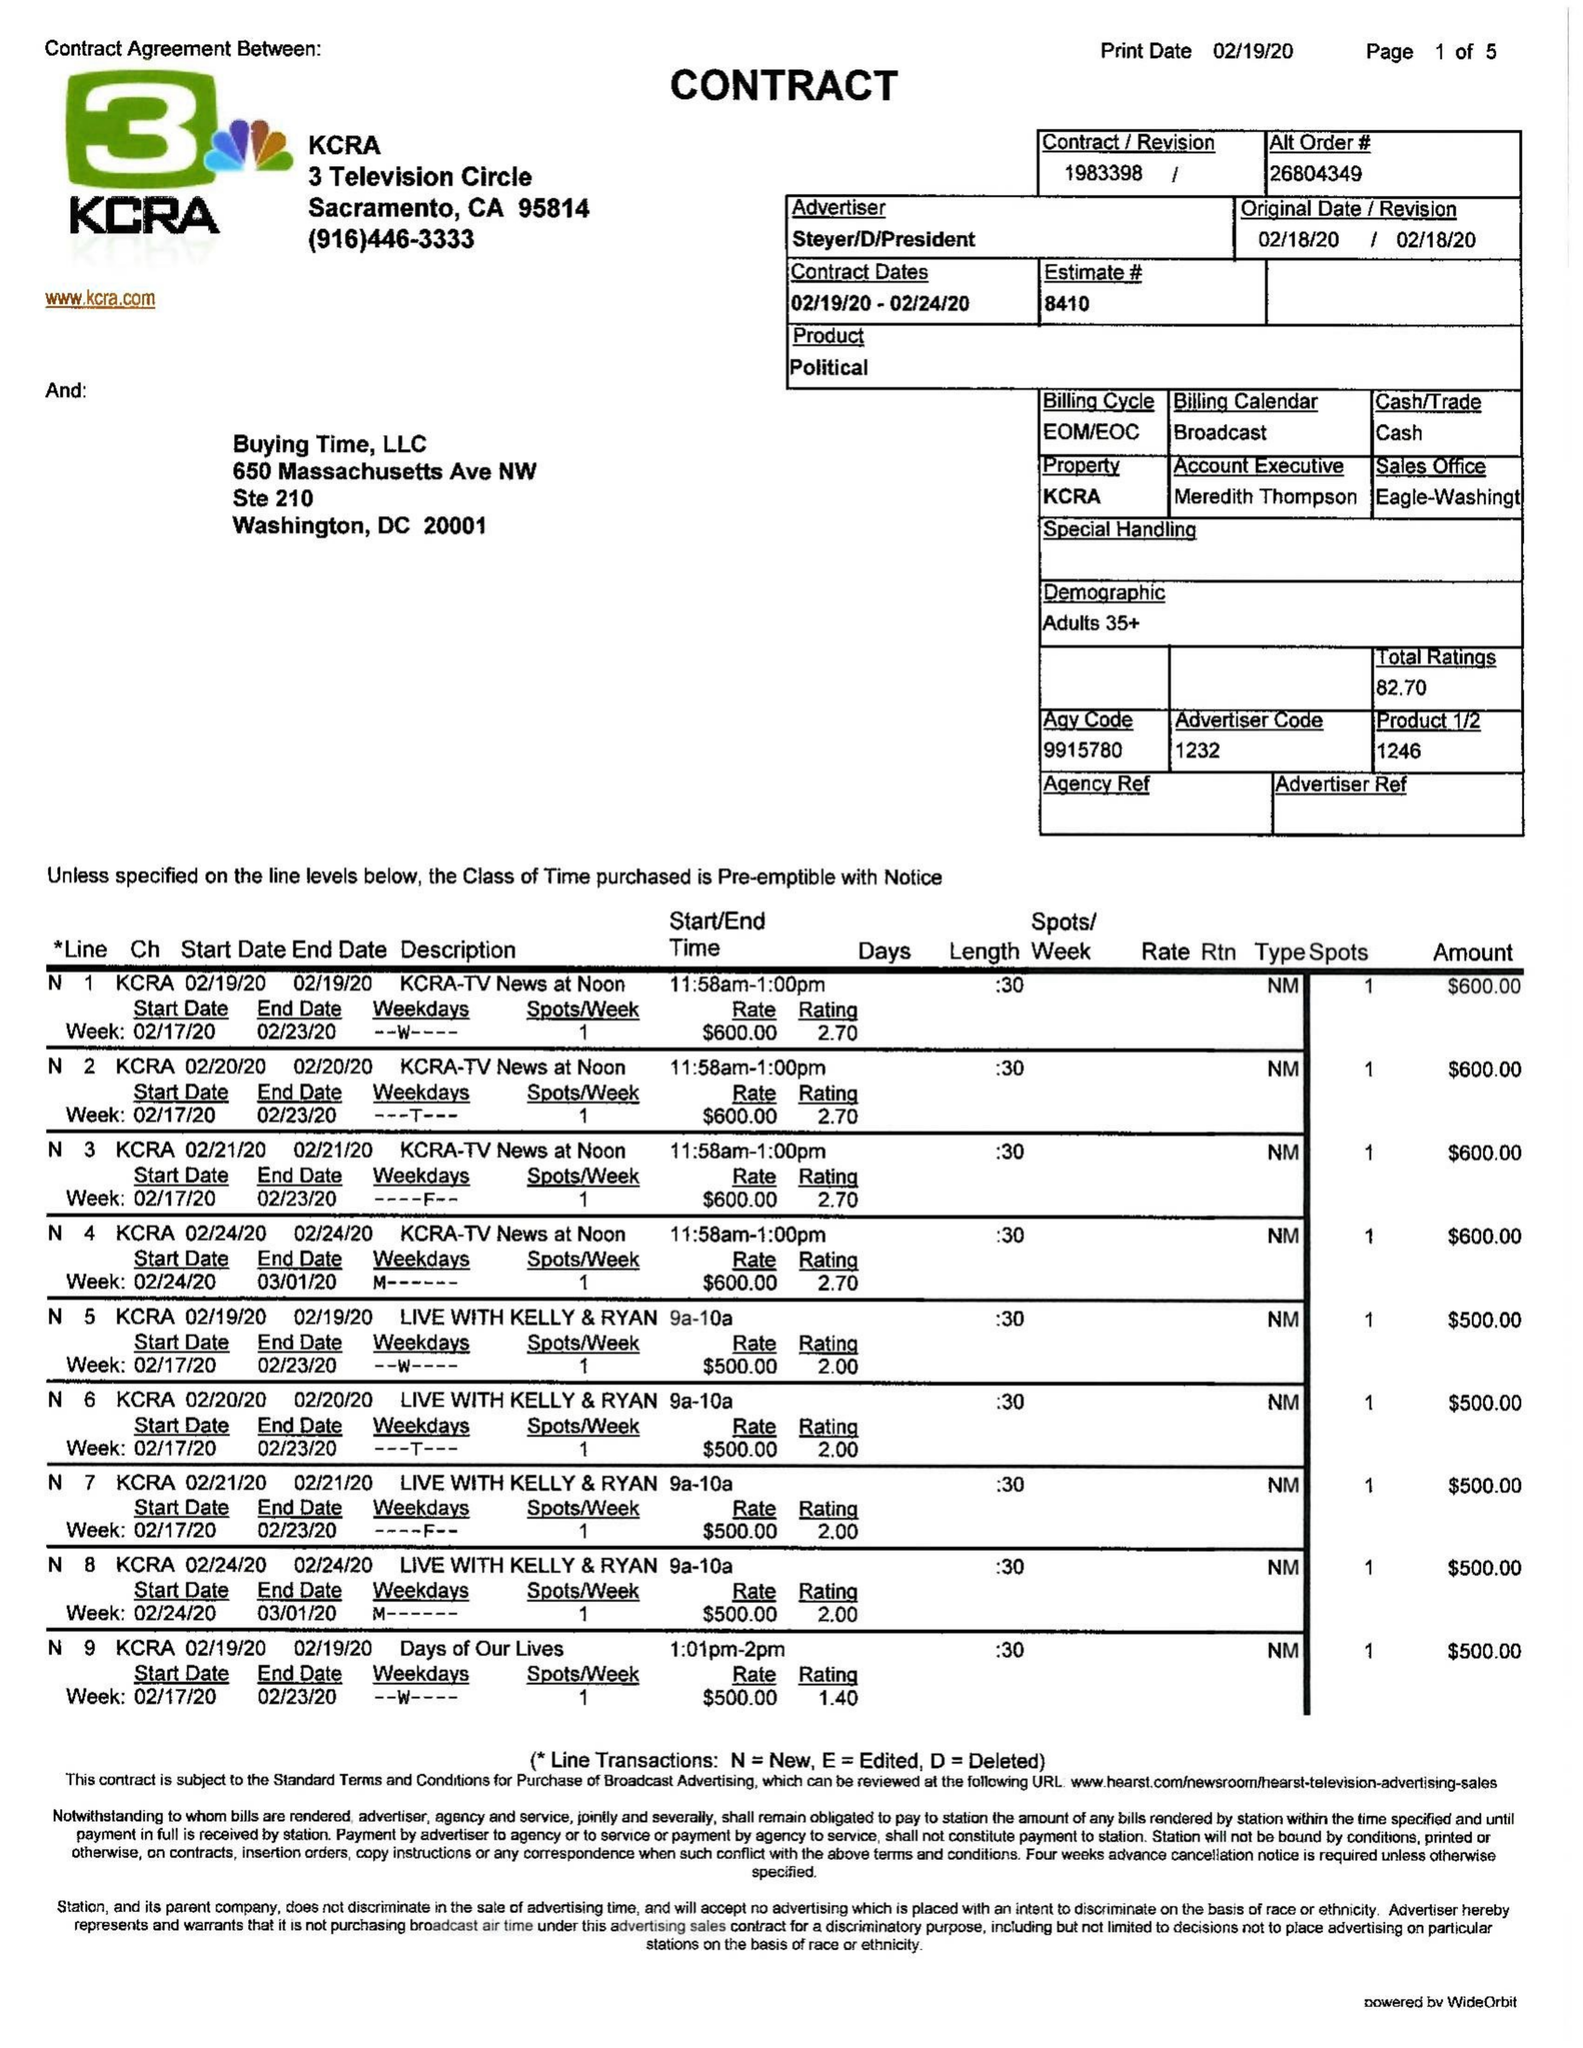What is the value for the contract_num?
Answer the question using a single word or phrase. 1983398 